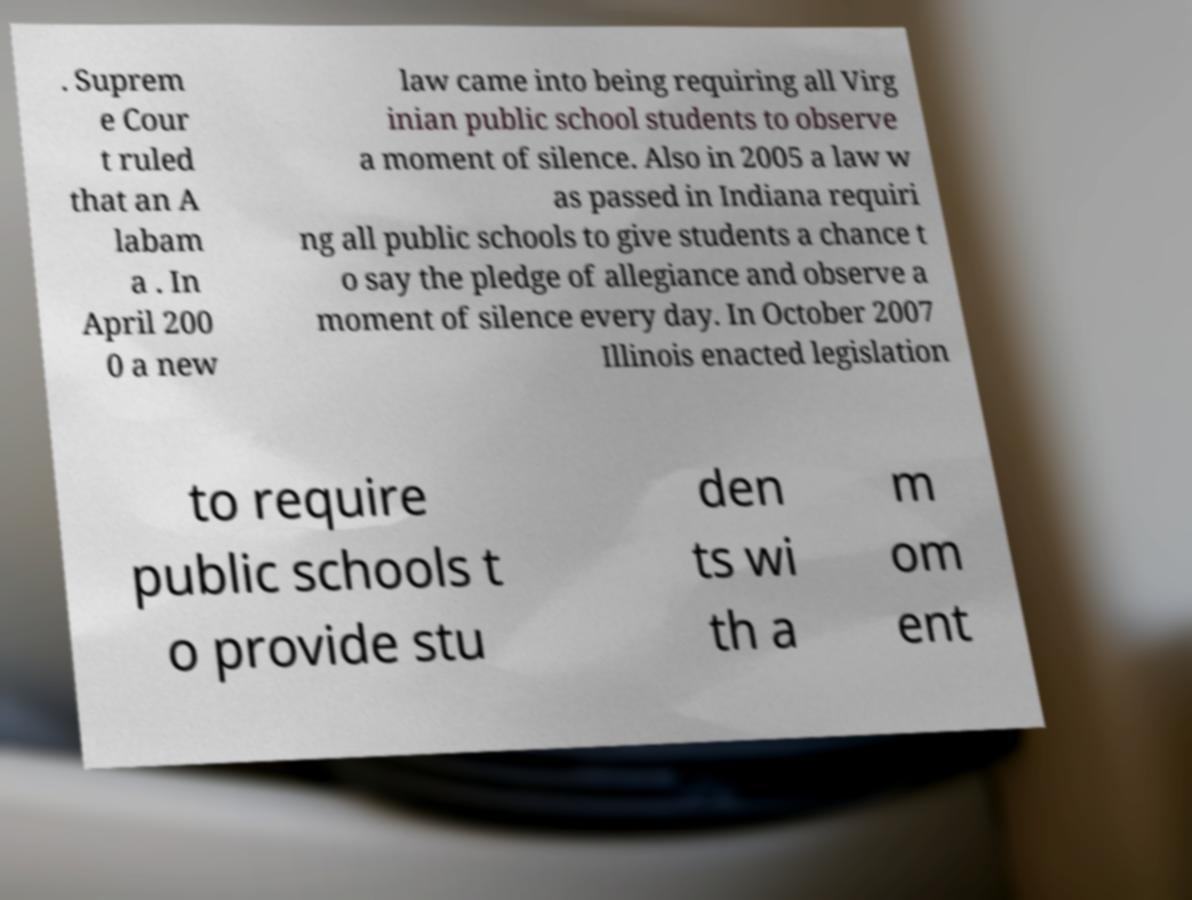Could you assist in decoding the text presented in this image and type it out clearly? . Suprem e Cour t ruled that an A labam a . In April 200 0 a new law came into being requiring all Virg inian public school students to observe a moment of silence. Also in 2005 a law w as passed in Indiana requiri ng all public schools to give students a chance t o say the pledge of allegiance and observe a moment of silence every day. In October 2007 Illinois enacted legislation to require public schools t o provide stu den ts wi th a m om ent 